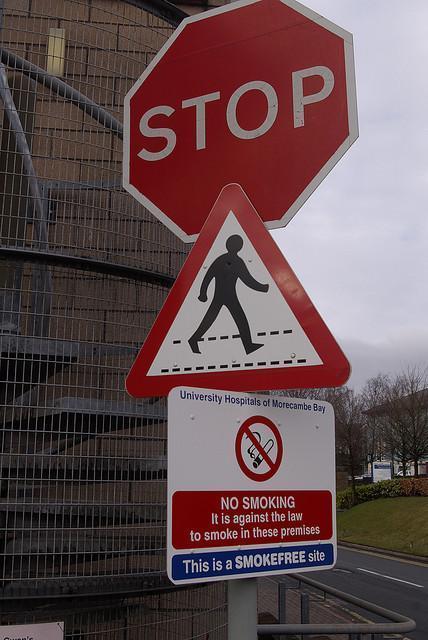How many street signs are on the poll?
Give a very brief answer. 3. How many signs are there?
Give a very brief answer. 3. How many stickers are on the stop sign?
Give a very brief answer. 0. How many people are in the picture?
Give a very brief answer. 0. 